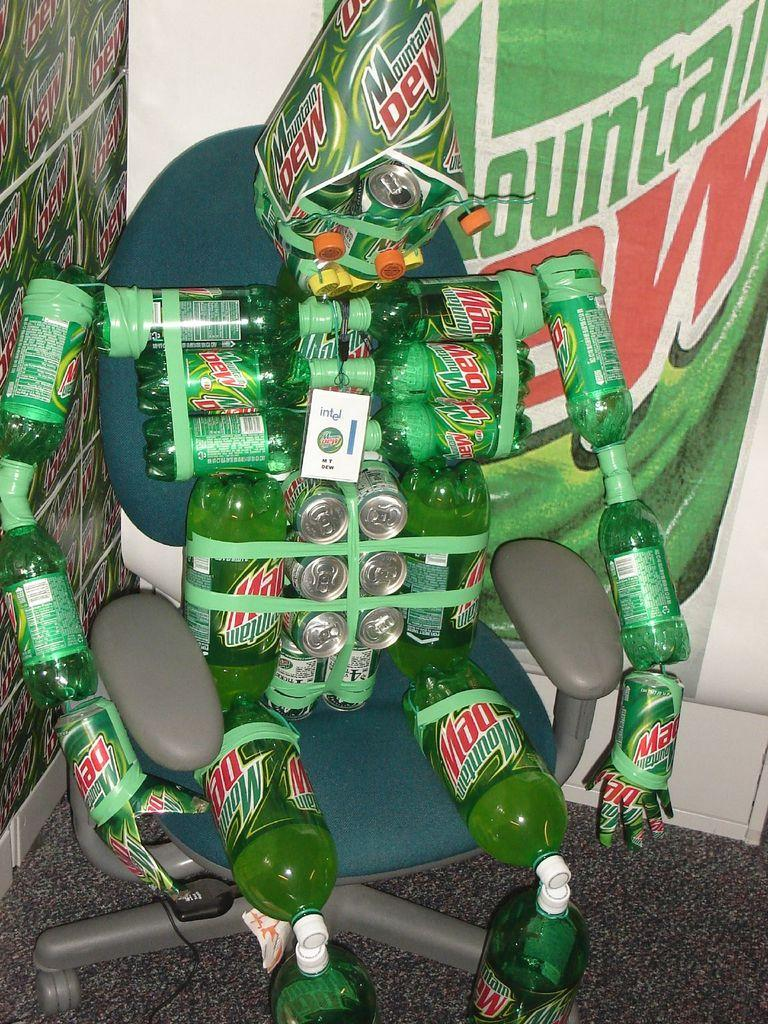<image>
Render a clear and concise summary of the photo. Deskchair that has mountain dew bottles taped to it with a square piece of paper with intel on it. 